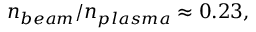Convert formula to latex. <formula><loc_0><loc_0><loc_500><loc_500>n _ { b e a m } / n _ { p l a s m a } \approx 0 . 2 3 ,</formula> 